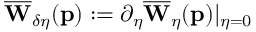Convert formula to latex. <formula><loc_0><loc_0><loc_500><loc_500>\overline { W } _ { \delta \eta } ( p ) \colon = \partial _ { \eta } \overline { W } _ { \eta } ( p ) | _ { \eta = 0 }</formula> 